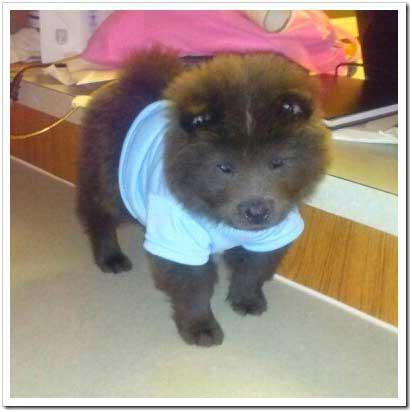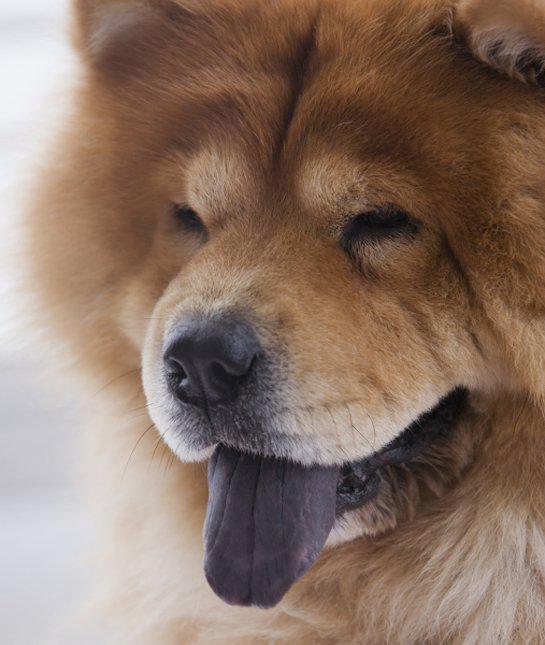The first image is the image on the left, the second image is the image on the right. Analyze the images presented: Is the assertion "Some of the dogs are standing in a row." valid? Answer yes or no. No. The first image is the image on the left, the second image is the image on the right. Given the left and right images, does the statement "All images show multiple chow puppies, and the left image contains at least five camera-facing puppies." hold true? Answer yes or no. No. 